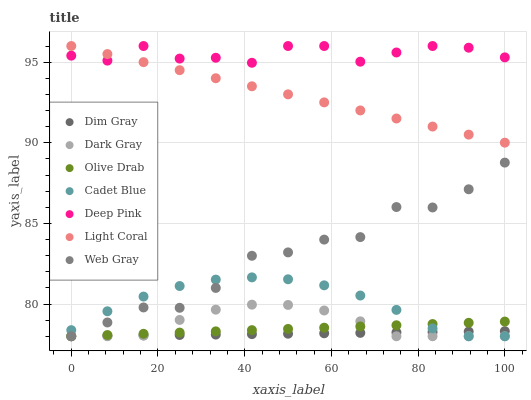Does Dim Gray have the minimum area under the curve?
Answer yes or no. Yes. Does Deep Pink have the maximum area under the curve?
Answer yes or no. Yes. Does Deep Pink have the minimum area under the curve?
Answer yes or no. No. Does Dim Gray have the maximum area under the curve?
Answer yes or no. No. Is Light Coral the smoothest?
Answer yes or no. Yes. Is Web Gray the roughest?
Answer yes or no. Yes. Is Dim Gray the smoothest?
Answer yes or no. No. Is Dim Gray the roughest?
Answer yes or no. No. Does Dim Gray have the lowest value?
Answer yes or no. Yes. Does Deep Pink have the lowest value?
Answer yes or no. No. Does Deep Pink have the highest value?
Answer yes or no. Yes. Does Dim Gray have the highest value?
Answer yes or no. No. Is Olive Drab less than Light Coral?
Answer yes or no. Yes. Is Light Coral greater than Web Gray?
Answer yes or no. Yes. Does Deep Pink intersect Light Coral?
Answer yes or no. Yes. Is Deep Pink less than Light Coral?
Answer yes or no. No. Is Deep Pink greater than Light Coral?
Answer yes or no. No. Does Olive Drab intersect Light Coral?
Answer yes or no. No. 